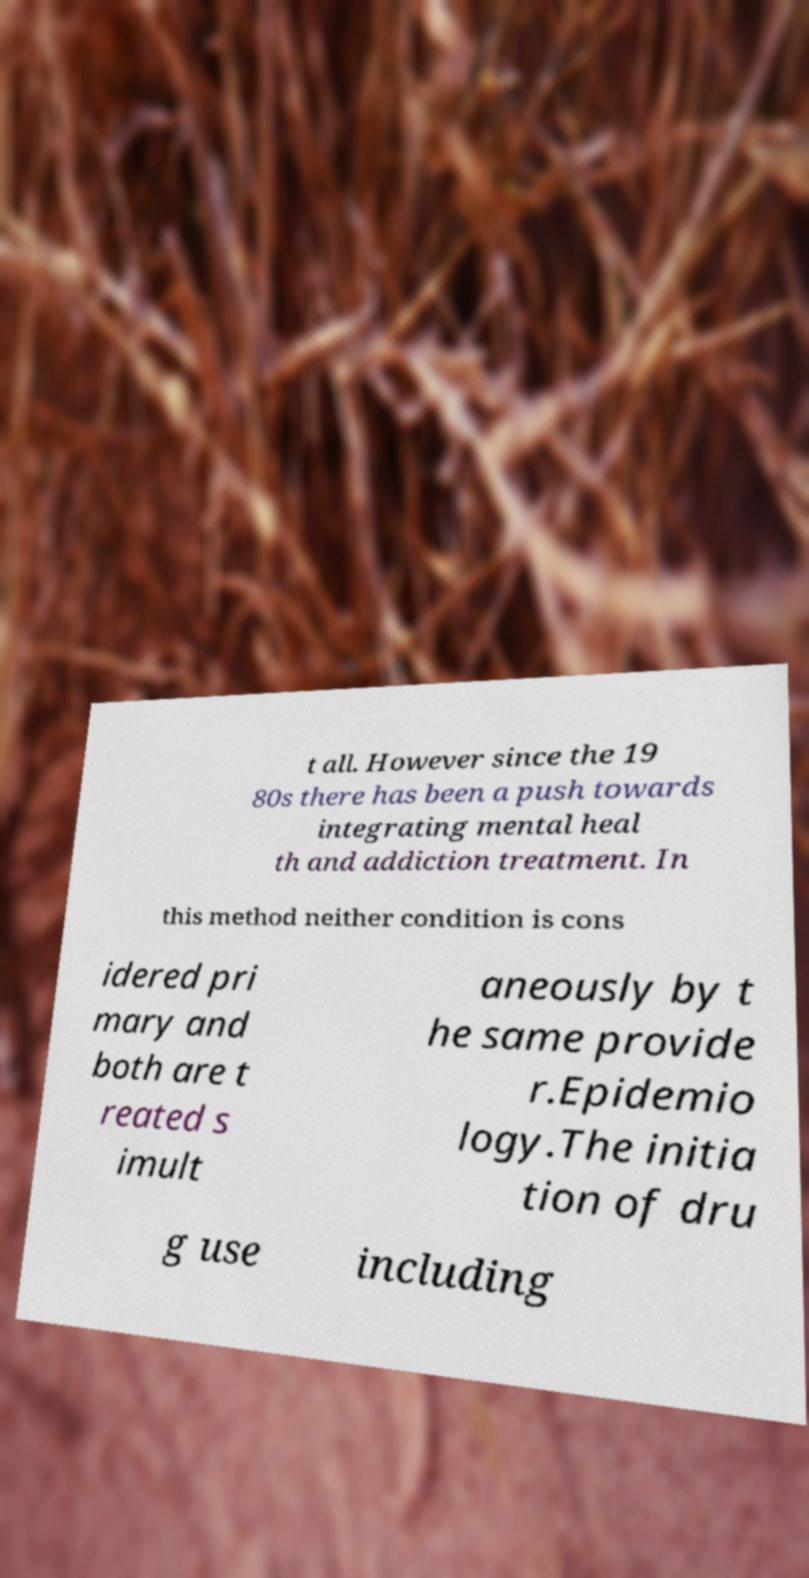I need the written content from this picture converted into text. Can you do that? t all. However since the 19 80s there has been a push towards integrating mental heal th and addiction treatment. In this method neither condition is cons idered pri mary and both are t reated s imult aneously by t he same provide r.Epidemio logy.The initia tion of dru g use including 